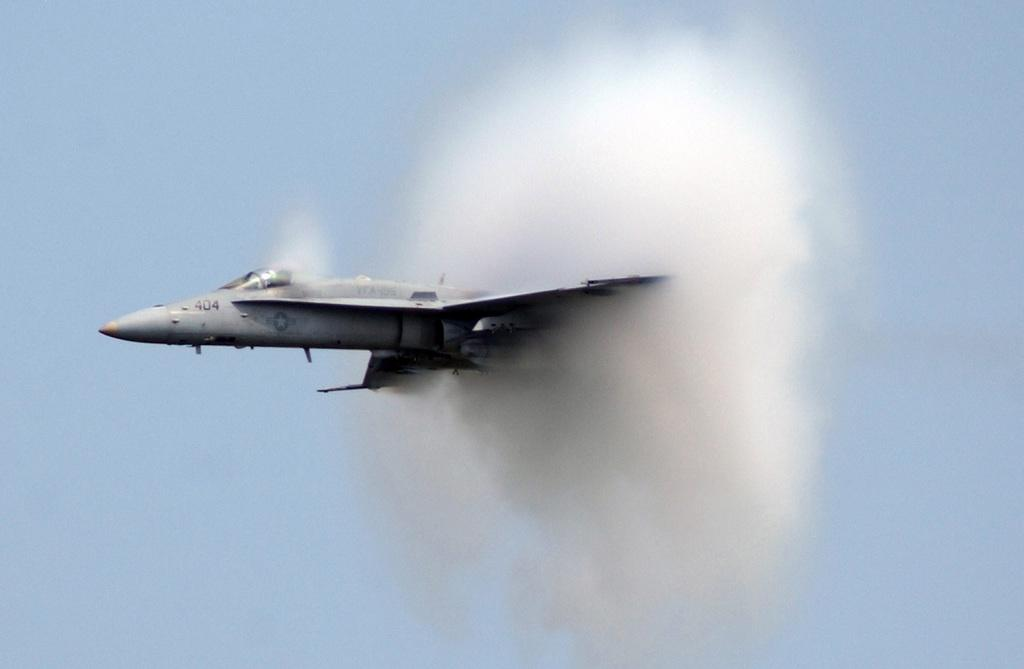<image>
Provide a brief description of the given image. plane 404 with smoke coming out of its tail up in the sky 